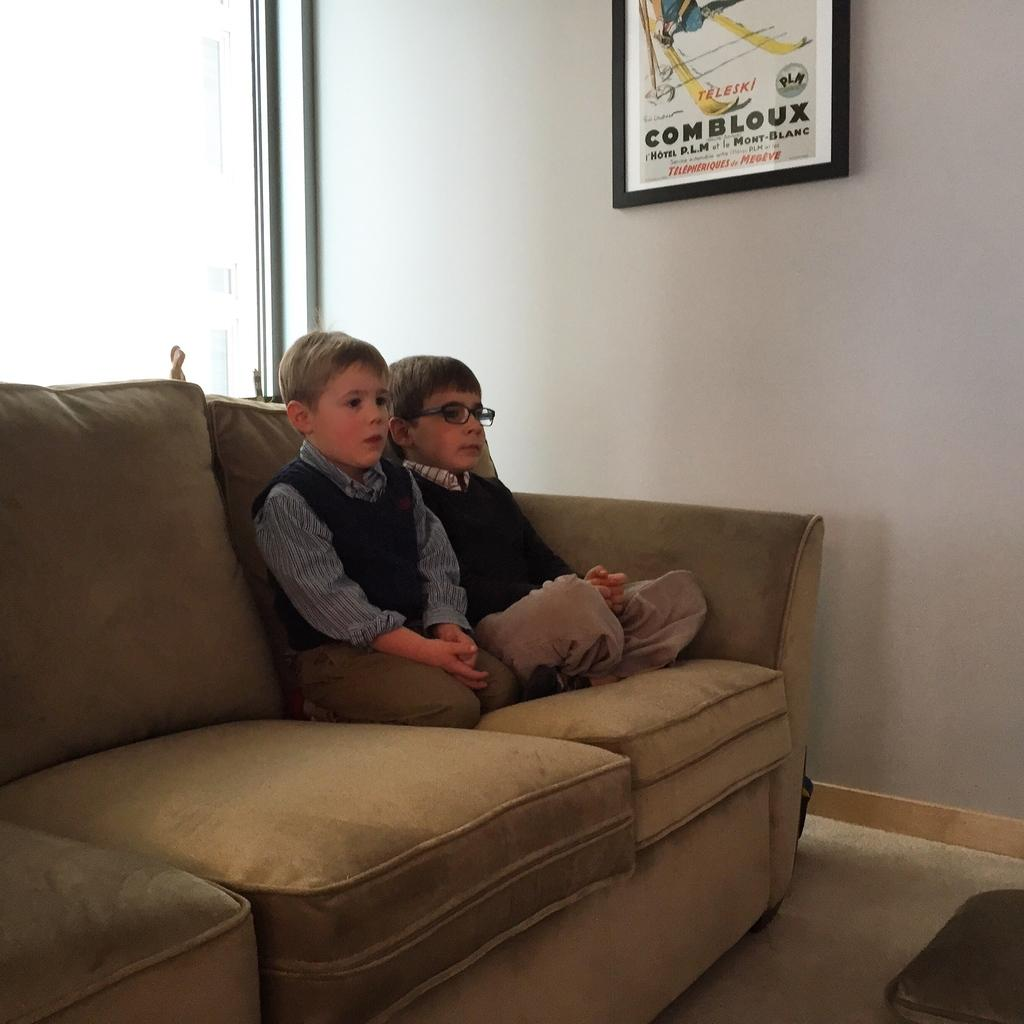How many children are present in the image? There are two children in the image. What are the children doing in the image? The children are sitting on a couch. What can be seen in the background of the image? There is a wall in the background of the image. Is there any decoration or object attached to the wall in the background? Yes, there is a photo frame attached to the wall in the background. Can you see a pen being used by one of the children in the image? No, there is no pen visible in the image. 